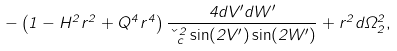Convert formula to latex. <formula><loc_0><loc_0><loc_500><loc_500>- \left ( 1 - H ^ { 2 } r ^ { 2 } + Q ^ { 4 } r ^ { 4 } \right ) \frac { 4 d V ^ { \prime } d W ^ { \prime } } { \kappa _ { c } ^ { 2 } \sin ( 2 V ^ { \prime } ) \sin ( 2 W ^ { \prime } ) } + r ^ { 2 } d \Omega _ { 2 } ^ { 2 } ,</formula> 